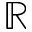Convert formula to latex. <formula><loc_0><loc_0><loc_500><loc_500>\mathbb { R }</formula> 